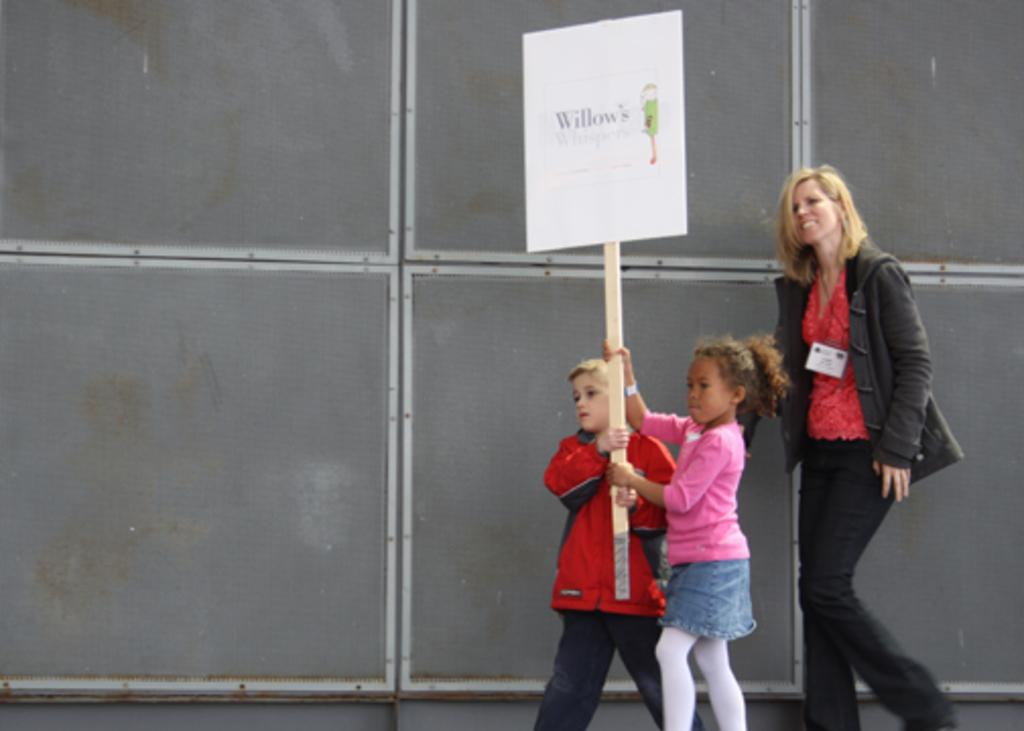Who is present in the image? There are children and a woman in the image. What are the children holding in the image? The children are holding placards in the image. What type of stew is being served to the kitten in the image? There is no kitten or stew present in the image. 